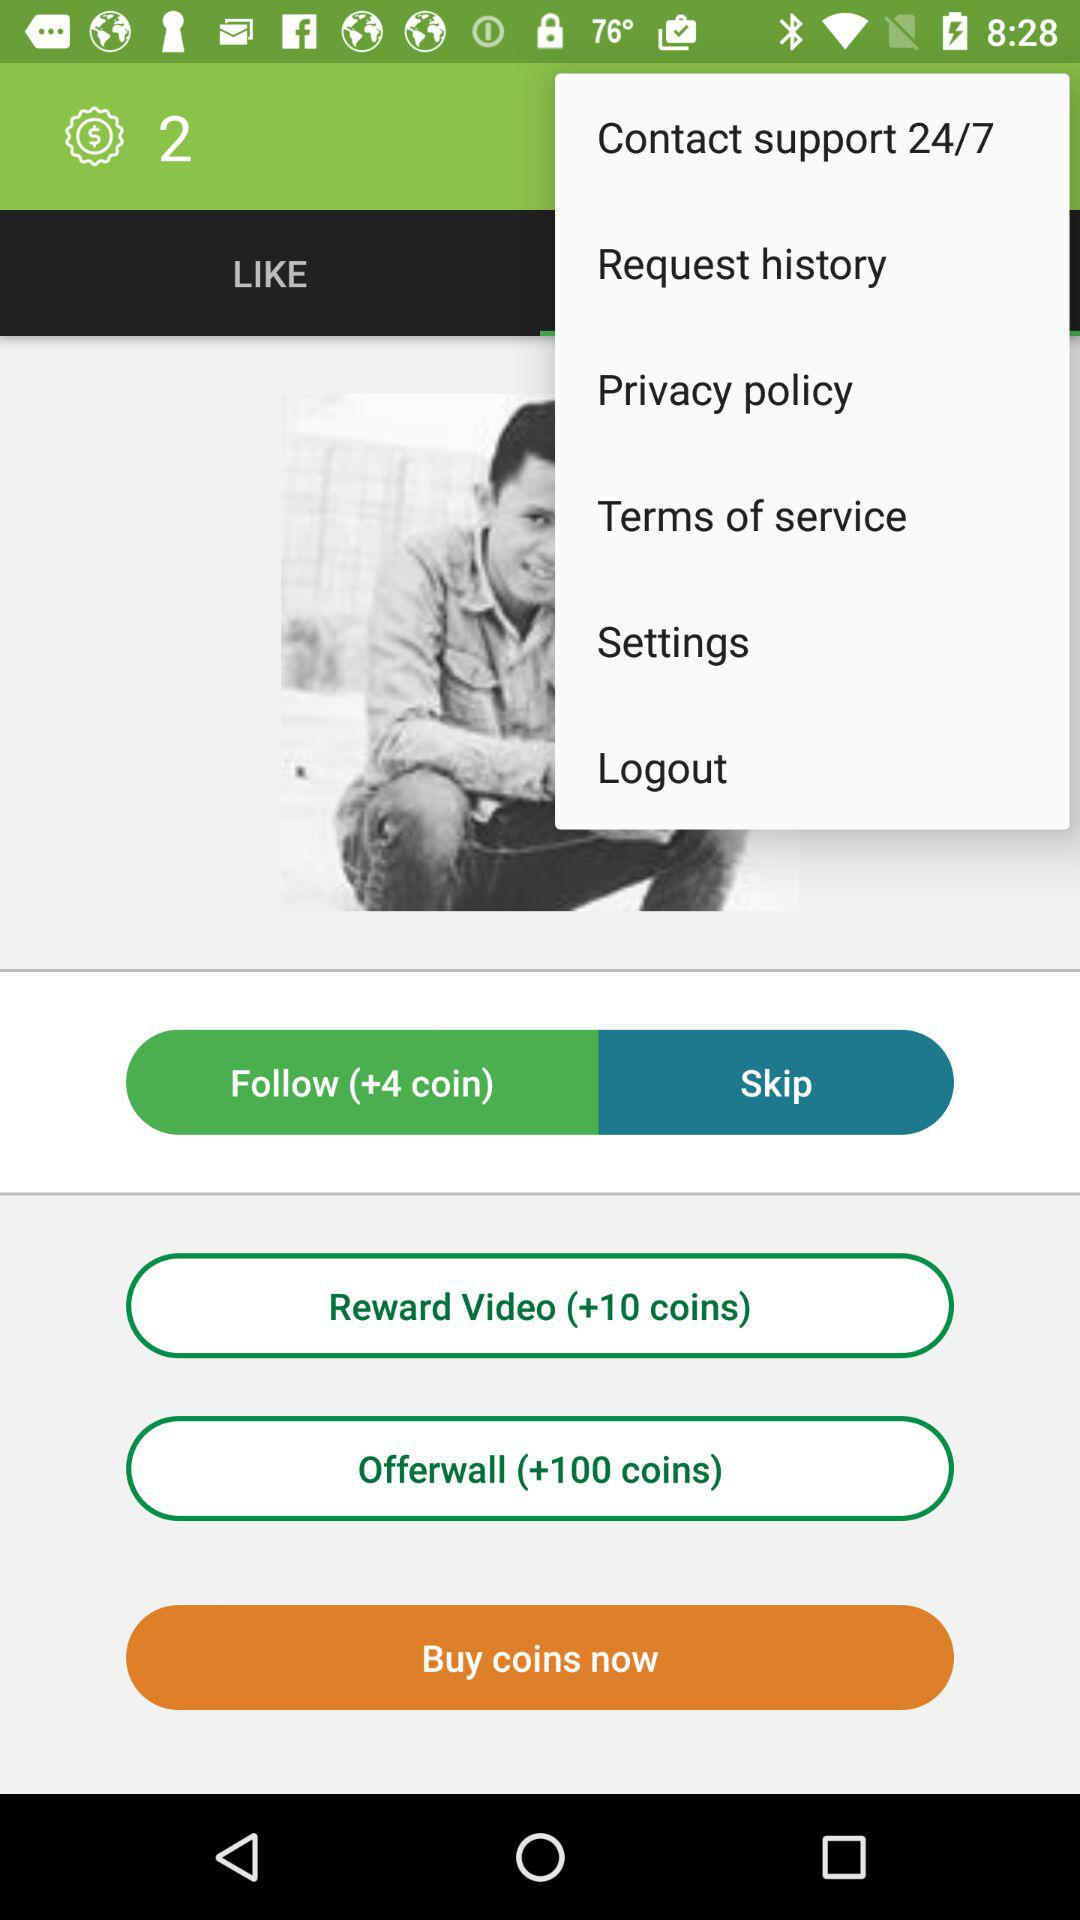How many coins will one get for watching the reward video? For watching the reward video, one will get 10 coins. 